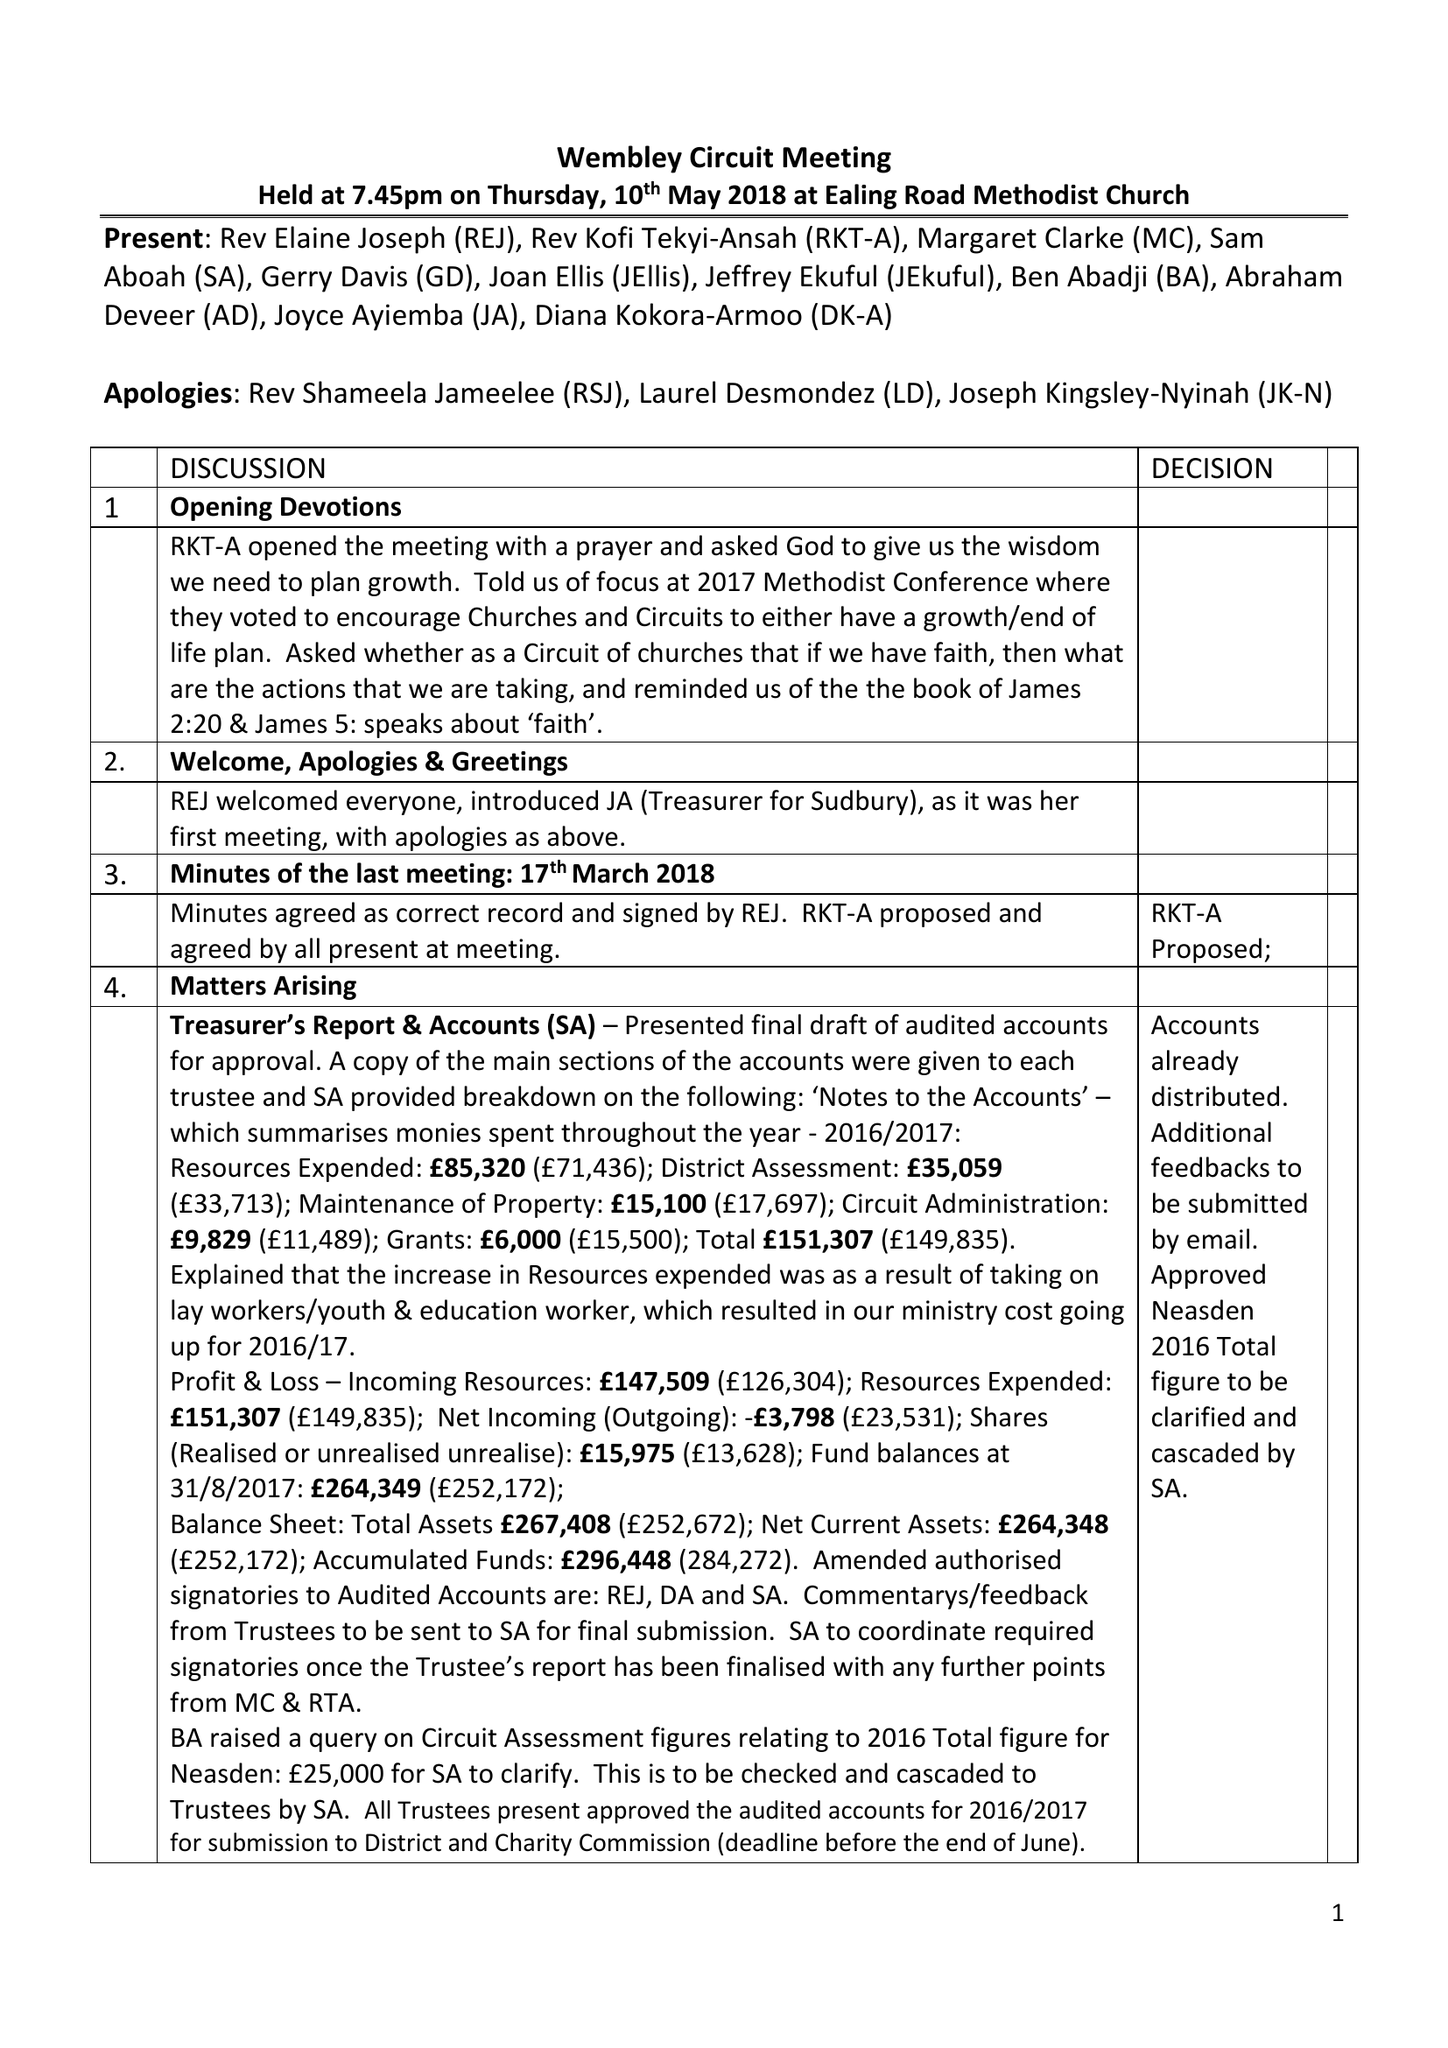What is the value for the address__post_town?
Answer the question using a single word or phrase. WEMBLEY 